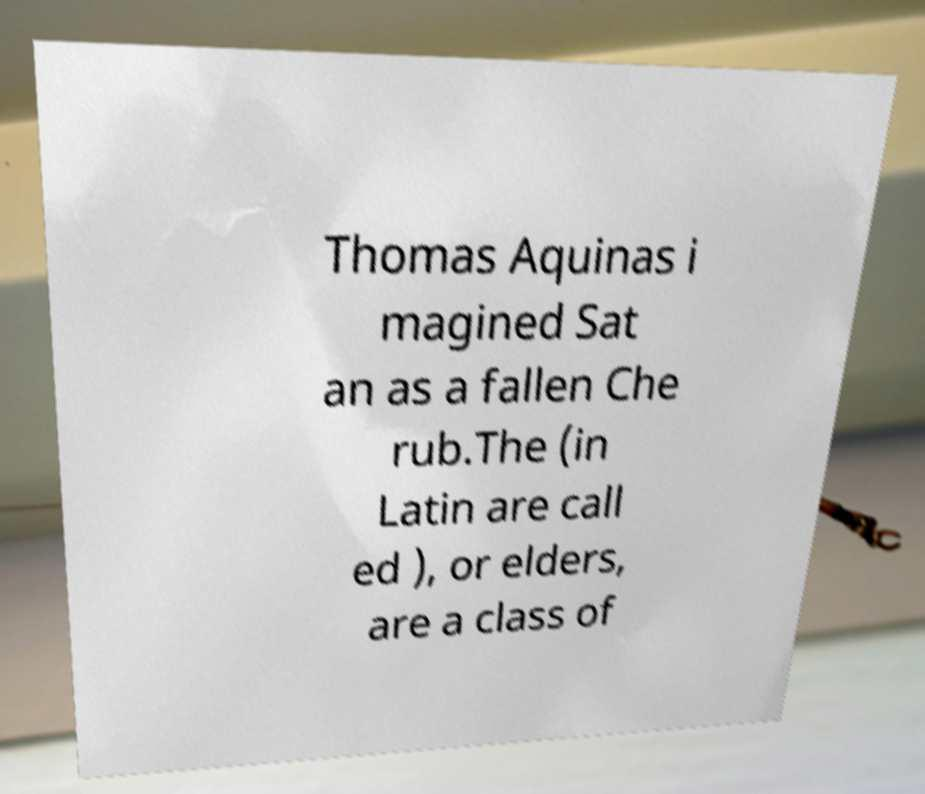For documentation purposes, I need the text within this image transcribed. Could you provide that? Thomas Aquinas i magined Sat an as a fallen Che rub.The (in Latin are call ed ), or elders, are a class of 